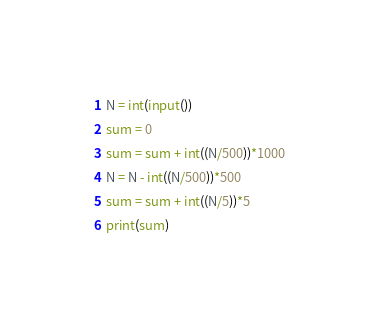<code> <loc_0><loc_0><loc_500><loc_500><_Python_>N = int(input())
sum = 0
sum = sum + int((N/500))*1000
N = N - int((N/500))*500
sum = sum + int((N/5))*5
print(sum)</code> 